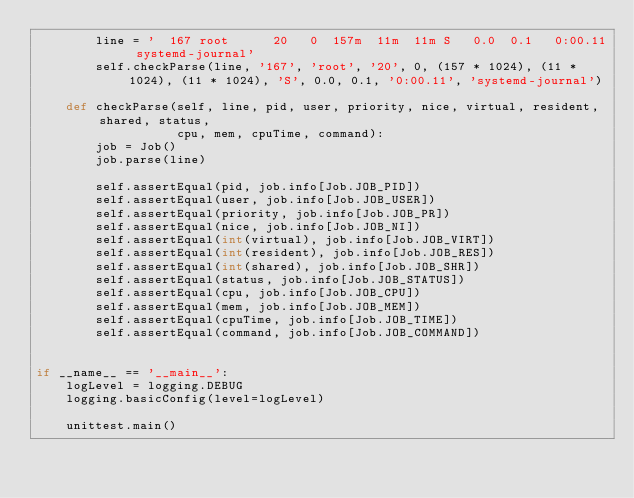Convert code to text. <code><loc_0><loc_0><loc_500><loc_500><_Python_>        line = '  167 root      20   0  157m  11m  11m S   0.0  0.1   0:00.11 systemd-journal'
        self.checkParse(line, '167', 'root', '20', 0, (157 * 1024), (11 * 1024), (11 * 1024), 'S', 0.0, 0.1, '0:00.11', 'systemd-journal')
        
    def checkParse(self, line, pid, user, priority, nice, virtual, resident, shared, status,
                   cpu, mem, cpuTime, command):
        job = Job()
        job.parse(line)

        self.assertEqual(pid, job.info[Job.JOB_PID])
        self.assertEqual(user, job.info[Job.JOB_USER])
        self.assertEqual(priority, job.info[Job.JOB_PR])
        self.assertEqual(nice, job.info[Job.JOB_NI])
        self.assertEqual(int(virtual), job.info[Job.JOB_VIRT])
        self.assertEqual(int(resident), job.info[Job.JOB_RES])
        self.assertEqual(int(shared), job.info[Job.JOB_SHR])
        self.assertEqual(status, job.info[Job.JOB_STATUS])
        self.assertEqual(cpu, job.info[Job.JOB_CPU])
        self.assertEqual(mem, job.info[Job.JOB_MEM])
        self.assertEqual(cpuTime, job.info[Job.JOB_TIME])
        self.assertEqual(command, job.info[Job.JOB_COMMAND])


if __name__ == '__main__':
    logLevel = logging.DEBUG
    logging.basicConfig(level=logLevel)

    unittest.main()
</code> 